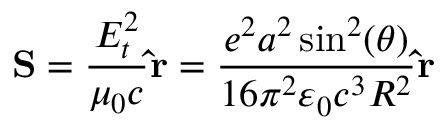Convert formula to latex. <formula><loc_0><loc_0><loc_500><loc_500>S = { \frac { E _ { t } ^ { 2 } } { \mu _ { 0 } c } } \hat { r } = { \frac { e ^ { 2 } a ^ { 2 } \sin ^ { 2 } ( \theta ) } { 1 6 \pi ^ { 2 } \varepsilon _ { 0 } c ^ { 3 } R ^ { 2 } } } \hat { r }</formula> 